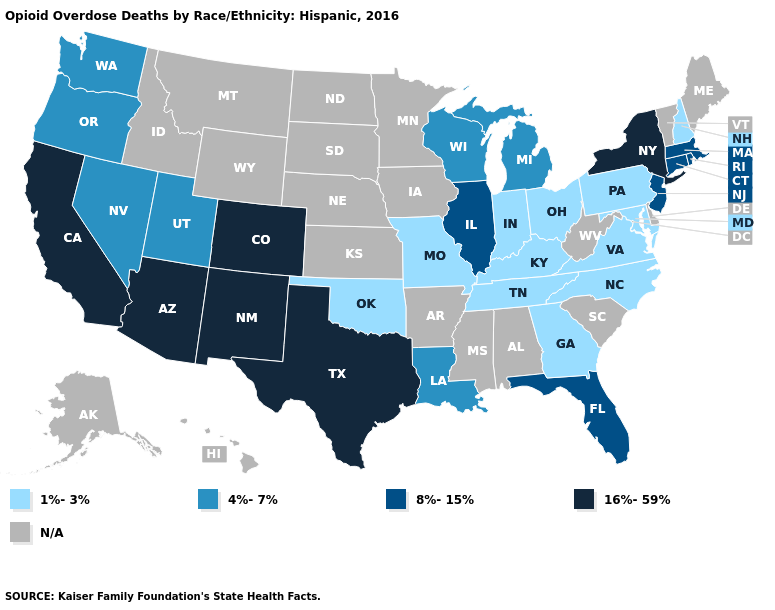Name the states that have a value in the range 1%-3%?
Answer briefly. Georgia, Indiana, Kentucky, Maryland, Missouri, New Hampshire, North Carolina, Ohio, Oklahoma, Pennsylvania, Tennessee, Virginia. What is the value of Ohio?
Give a very brief answer. 1%-3%. What is the value of Arizona?
Give a very brief answer. 16%-59%. What is the value of Nevada?
Keep it brief. 4%-7%. What is the value of California?
Keep it brief. 16%-59%. Which states hav the highest value in the MidWest?
Write a very short answer. Illinois. What is the highest value in states that border Ohio?
Give a very brief answer. 4%-7%. What is the value of Oregon?
Quick response, please. 4%-7%. What is the highest value in states that border New York?
Give a very brief answer. 8%-15%. What is the value of North Dakota?
Answer briefly. N/A. Name the states that have a value in the range 1%-3%?
Write a very short answer. Georgia, Indiana, Kentucky, Maryland, Missouri, New Hampshire, North Carolina, Ohio, Oklahoma, Pennsylvania, Tennessee, Virginia. Does Indiana have the lowest value in the MidWest?
Quick response, please. Yes. How many symbols are there in the legend?
Answer briefly. 5. 